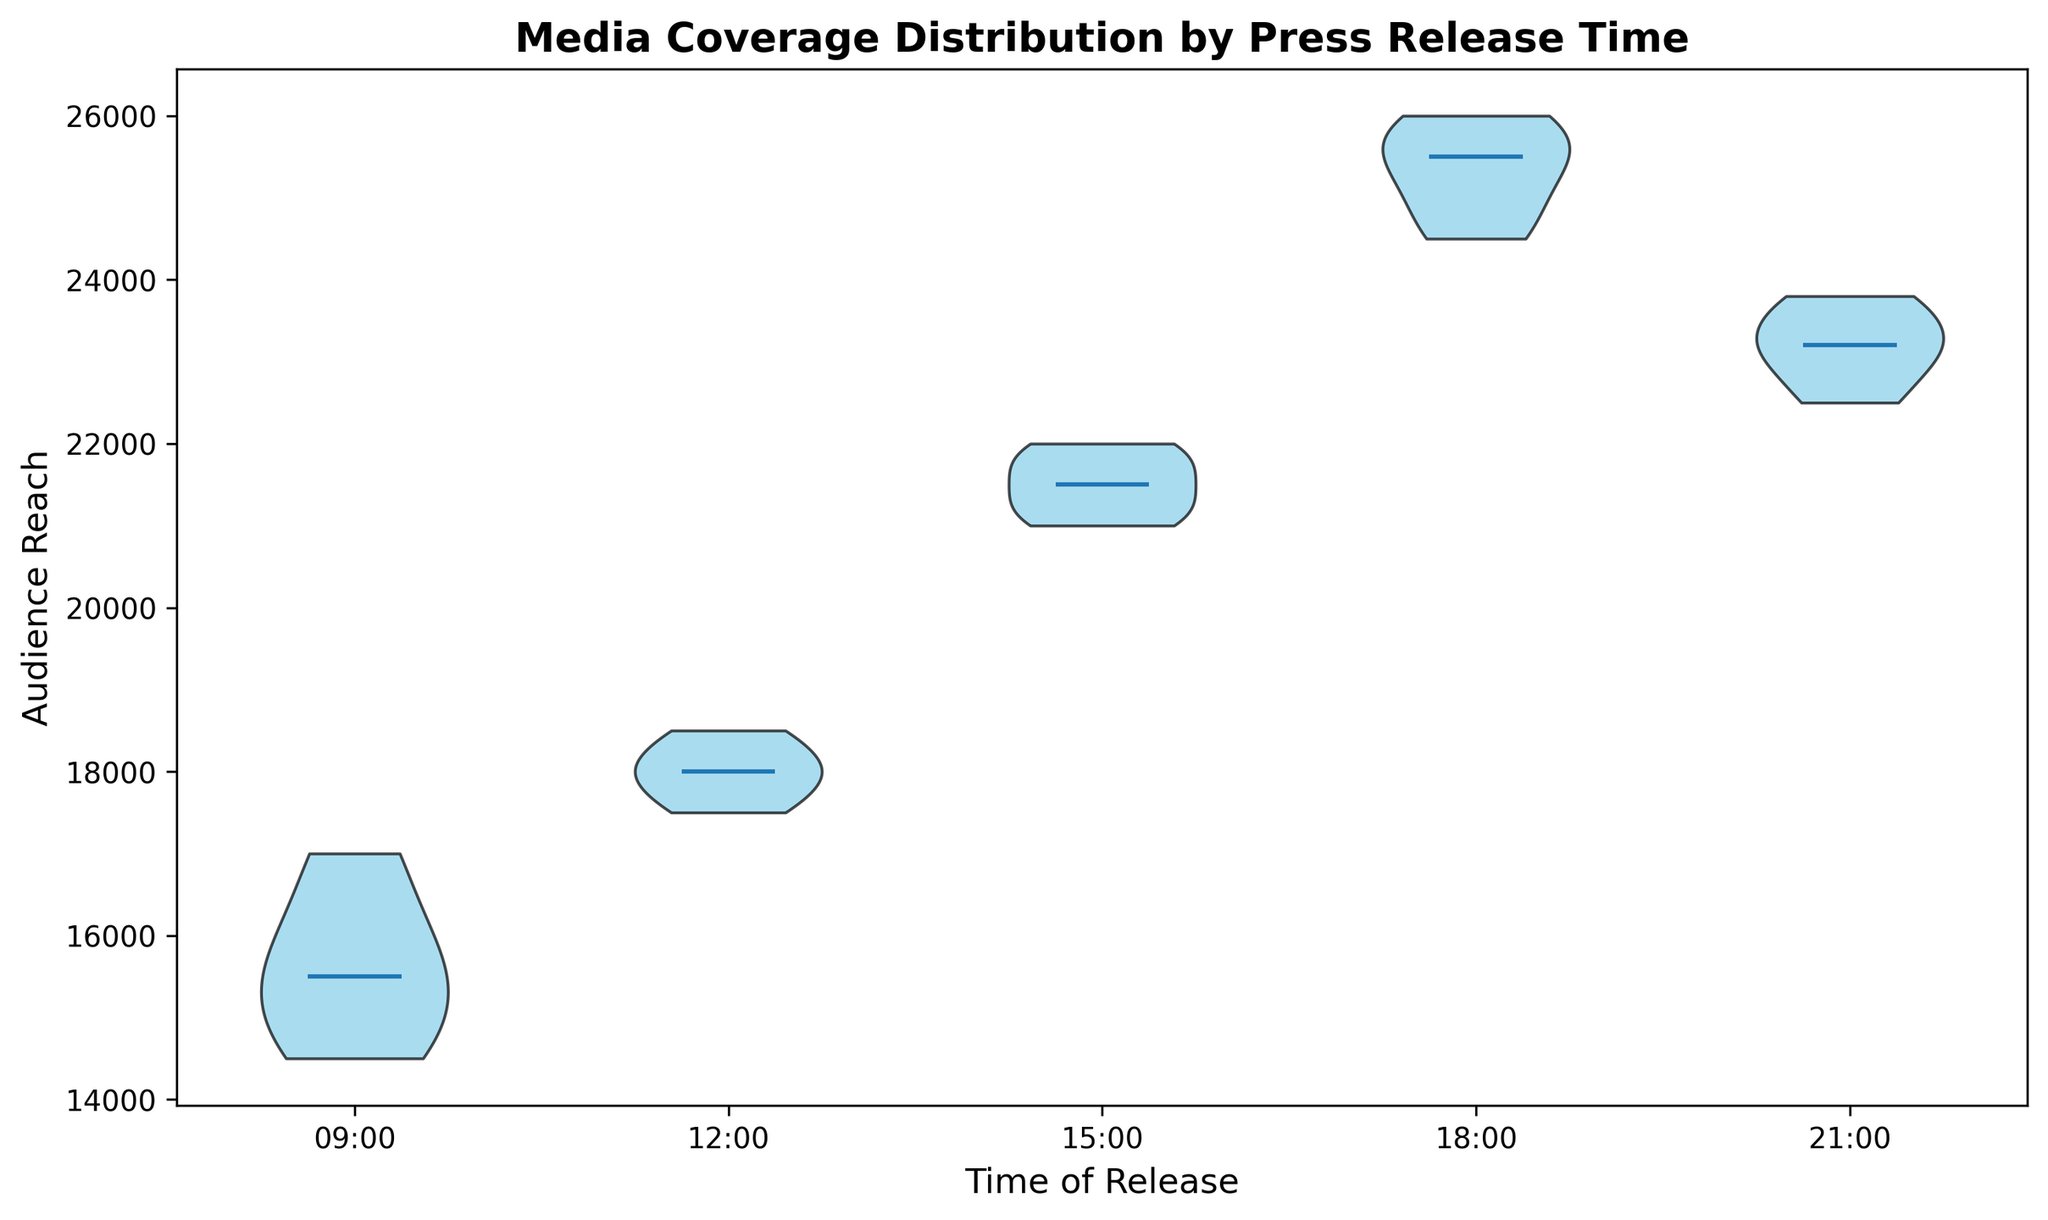What is the median audience reach for the press releases at 09:00? The violin plot shows a white dot at the center of each violin, representing the median of the distribution. For the time 09:00, the white dot is located at 15500.
Answer: 15500 Which time slot has the highest median audience reach? By looking at the white dots (medians) in the violin plots, the highest position is observed at 18:00.
Answer: 18:00 How does the spread of audience reach at 21:00 compare to 12:00? Observing the width and spread of the violin plots, 21:00 has a slightly narrower spread whereas 12:00 has a wider distribution.
Answer: 21:00 has a narrower spread Which time slot shows the least variation in audience reach? The width and compactness of the violin plot indicate variation. The 21:00 slot appears the most compact, indicating the least variation.
Answer: 21:00 What is the range of audience reach for the press releases at 15:00? To determine the range, look at the top and bottom of the violin plot at 15:00. The range extends from 21000 to 22000. Thus, the range is 22000 - 21000 = 1000.
Answer: 1000 Does the audience reach consistently increase over the day? By examining the rising medians from 09:00 to 18:00 and a dip at 21:00, we can infer that the reach increases until 18:00 but drops slightly afterward.
Answer: Increases until 18:00, then drops Between 15:00 and 18:00, which time slot has a higher median value? By comparing the position of the white dots (medians) for both times, 18:00 has a higher median than 15:00.
Answer: 18:00 How does the audience reach distribution at 09:00 compare to 15:00? To compare the distribution, look at the shapes of both violins. 09:00 has a slightly wider spread, whereas 15:00 is narrower and more compact indicating less spread and higher audience reach.
Answer: 09:00 has a wider spread What can you infer about audience reach at different times of release based on the plot's color? The color uniformity, with all being sky blue, suggests that the overall distributions are consistent and visually emphasize the shape and spread without color bias.
Answer: Consistent distribution representation Looking at the overall pattern, which time slot would be optimal for releasing a press release to maximize audience reach? Observing the medians, the highest median audience reach is at 18:00, indicating it as the optimal release time to maximize audience reach.
Answer: 18:00 